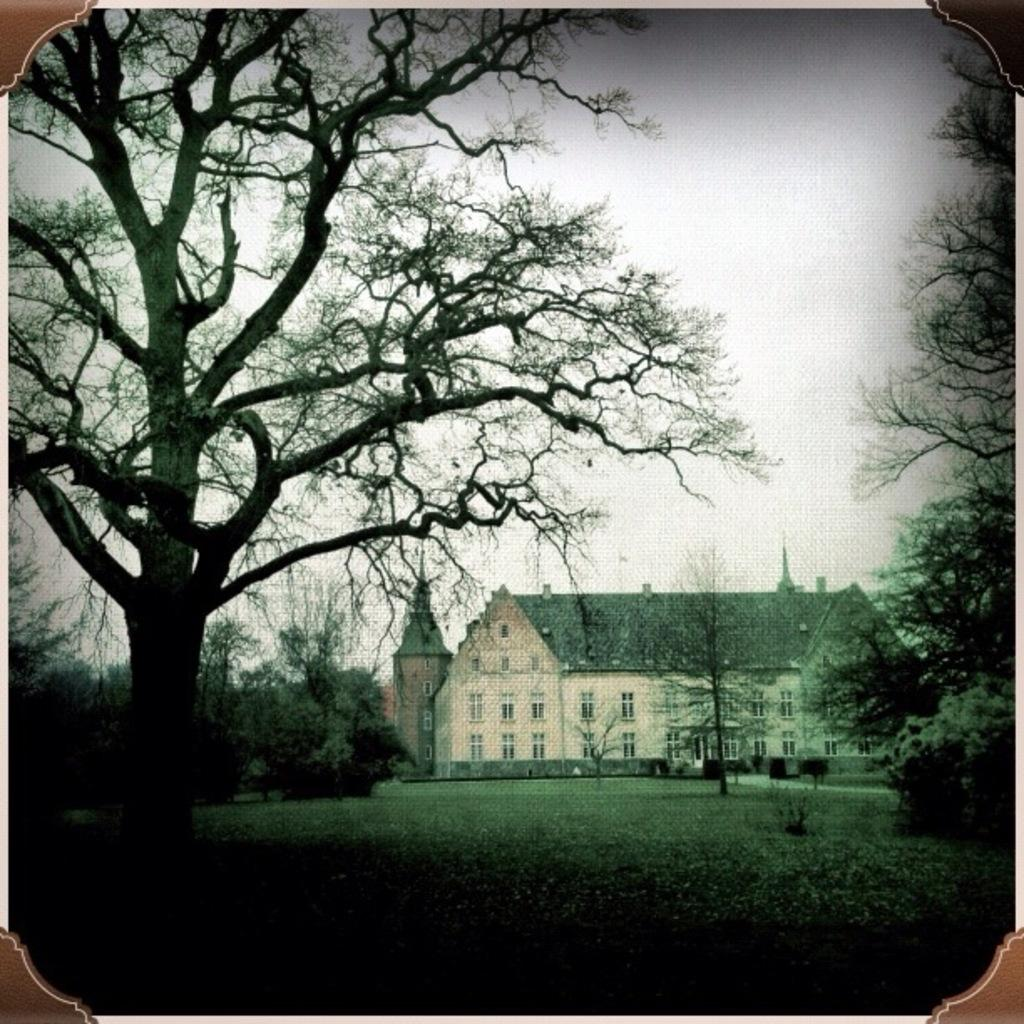What type of vegetation is present in the image? There are trees in the image. What structure can be seen in the middle of the image? There is a roof house in the middle of the image. What is visible at the top of the image? The sky is visible at the top of the image. How many lizards are sitting on the roof of the house in the image? There are no lizards present in the image. What type of shirt is the person wearing in the image? There is no person wearing a shirt in the image. 